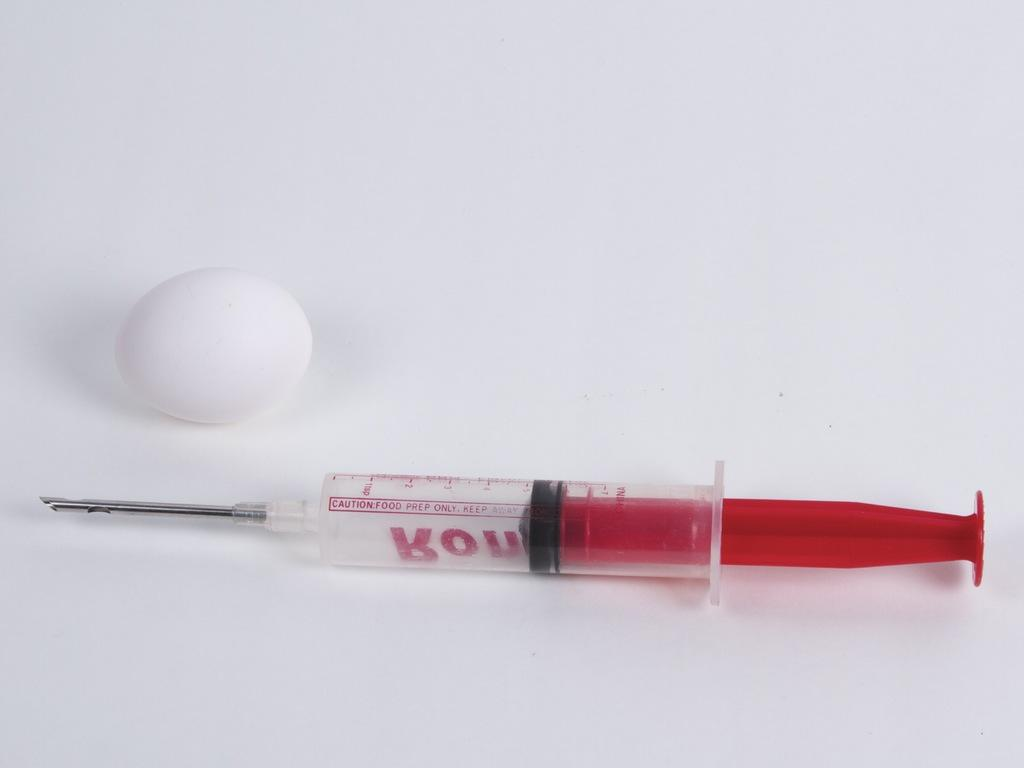What is the main object in the center of the image? There is a syringe in the center of the image. Are there any other objects visible in the image? Yes, there is an egg in the image. What type of veil is draped over the egg in the image? There is no veil present in the image; it only features a syringe and an egg. Can you tell me the account number associated with the egg in the image? There is no account number associated with the egg in the image, as it is not a financial transaction or related to any account. 